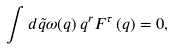<formula> <loc_0><loc_0><loc_500><loc_500>\int d \tilde { q } \omega ( q ) \, q ^ { r } F ^ { \tau } \left ( q \right ) = 0 ,</formula> 